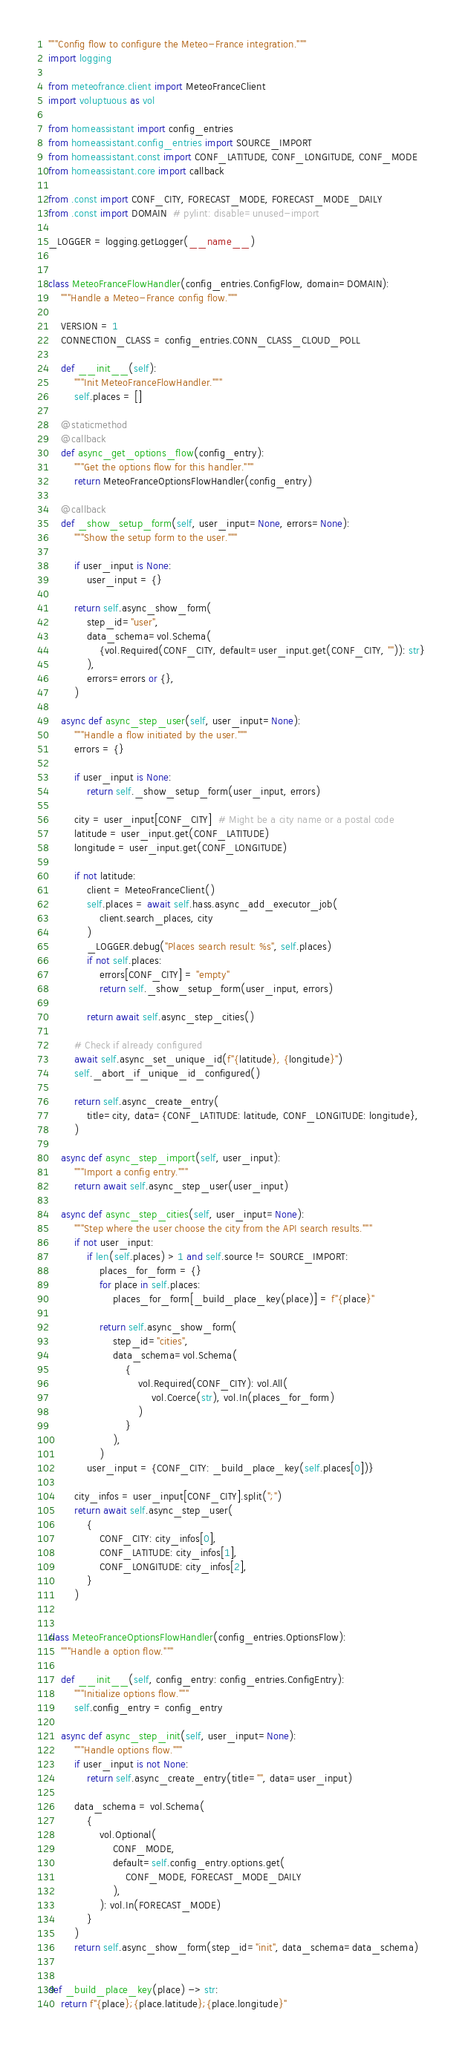<code> <loc_0><loc_0><loc_500><loc_500><_Python_>"""Config flow to configure the Meteo-France integration."""
import logging

from meteofrance.client import MeteoFranceClient
import voluptuous as vol

from homeassistant import config_entries
from homeassistant.config_entries import SOURCE_IMPORT
from homeassistant.const import CONF_LATITUDE, CONF_LONGITUDE, CONF_MODE
from homeassistant.core import callback

from .const import CONF_CITY, FORECAST_MODE, FORECAST_MODE_DAILY
from .const import DOMAIN  # pylint: disable=unused-import

_LOGGER = logging.getLogger(__name__)


class MeteoFranceFlowHandler(config_entries.ConfigFlow, domain=DOMAIN):
    """Handle a Meteo-France config flow."""

    VERSION = 1
    CONNECTION_CLASS = config_entries.CONN_CLASS_CLOUD_POLL

    def __init__(self):
        """Init MeteoFranceFlowHandler."""
        self.places = []

    @staticmethod
    @callback
    def async_get_options_flow(config_entry):
        """Get the options flow for this handler."""
        return MeteoFranceOptionsFlowHandler(config_entry)

    @callback
    def _show_setup_form(self, user_input=None, errors=None):
        """Show the setup form to the user."""

        if user_input is None:
            user_input = {}

        return self.async_show_form(
            step_id="user",
            data_schema=vol.Schema(
                {vol.Required(CONF_CITY, default=user_input.get(CONF_CITY, "")): str}
            ),
            errors=errors or {},
        )

    async def async_step_user(self, user_input=None):
        """Handle a flow initiated by the user."""
        errors = {}

        if user_input is None:
            return self._show_setup_form(user_input, errors)

        city = user_input[CONF_CITY]  # Might be a city name or a postal code
        latitude = user_input.get(CONF_LATITUDE)
        longitude = user_input.get(CONF_LONGITUDE)

        if not latitude:
            client = MeteoFranceClient()
            self.places = await self.hass.async_add_executor_job(
                client.search_places, city
            )
            _LOGGER.debug("Places search result: %s", self.places)
            if not self.places:
                errors[CONF_CITY] = "empty"
                return self._show_setup_form(user_input, errors)

            return await self.async_step_cities()

        # Check if already configured
        await self.async_set_unique_id(f"{latitude}, {longitude}")
        self._abort_if_unique_id_configured()

        return self.async_create_entry(
            title=city, data={CONF_LATITUDE: latitude, CONF_LONGITUDE: longitude},
        )

    async def async_step_import(self, user_input):
        """Import a config entry."""
        return await self.async_step_user(user_input)

    async def async_step_cities(self, user_input=None):
        """Step where the user choose the city from the API search results."""
        if not user_input:
            if len(self.places) > 1 and self.source != SOURCE_IMPORT:
                places_for_form = {}
                for place in self.places:
                    places_for_form[_build_place_key(place)] = f"{place}"

                return self.async_show_form(
                    step_id="cities",
                    data_schema=vol.Schema(
                        {
                            vol.Required(CONF_CITY): vol.All(
                                vol.Coerce(str), vol.In(places_for_form)
                            )
                        }
                    ),
                )
            user_input = {CONF_CITY: _build_place_key(self.places[0])}

        city_infos = user_input[CONF_CITY].split(";")
        return await self.async_step_user(
            {
                CONF_CITY: city_infos[0],
                CONF_LATITUDE: city_infos[1],
                CONF_LONGITUDE: city_infos[2],
            }
        )


class MeteoFranceOptionsFlowHandler(config_entries.OptionsFlow):
    """Handle a option flow."""

    def __init__(self, config_entry: config_entries.ConfigEntry):
        """Initialize options flow."""
        self.config_entry = config_entry

    async def async_step_init(self, user_input=None):
        """Handle options flow."""
        if user_input is not None:
            return self.async_create_entry(title="", data=user_input)

        data_schema = vol.Schema(
            {
                vol.Optional(
                    CONF_MODE,
                    default=self.config_entry.options.get(
                        CONF_MODE, FORECAST_MODE_DAILY
                    ),
                ): vol.In(FORECAST_MODE)
            }
        )
        return self.async_show_form(step_id="init", data_schema=data_schema)


def _build_place_key(place) -> str:
    return f"{place};{place.latitude};{place.longitude}"
</code> 